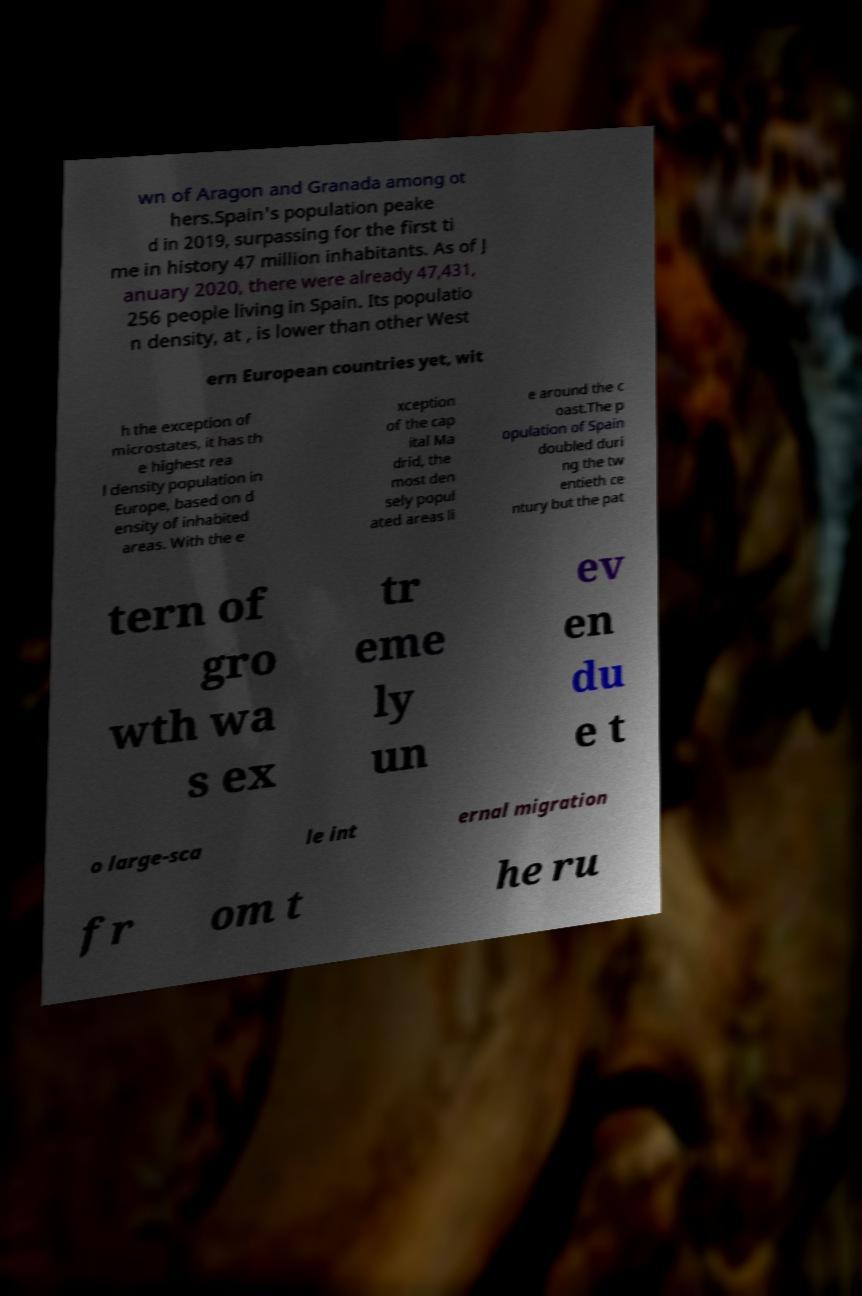Please read and relay the text visible in this image. What does it say? wn of Aragon and Granada among ot hers.Spain's population peake d in 2019, surpassing for the first ti me in history 47 million inhabitants. As of J anuary 2020, there were already 47,431, 256 people living in Spain. Its populatio n density, at , is lower than other West ern European countries yet, wit h the exception of microstates, it has th e highest rea l density population in Europe, based on d ensity of inhabited areas. With the e xception of the cap ital Ma drid, the most den sely popul ated areas li e around the c oast.The p opulation of Spain doubled duri ng the tw entieth ce ntury but the pat tern of gro wth wa s ex tr eme ly un ev en du e t o large-sca le int ernal migration fr om t he ru 